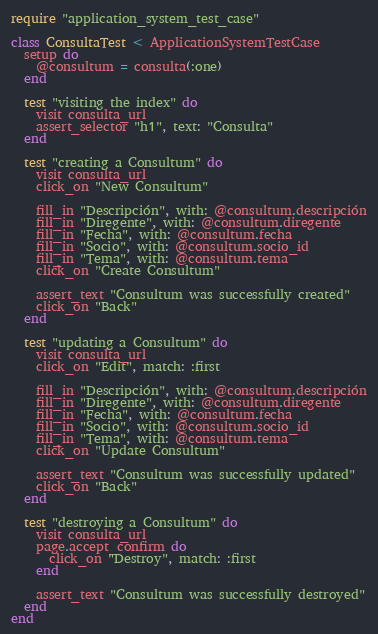<code> <loc_0><loc_0><loc_500><loc_500><_Ruby_>require "application_system_test_case"

class ConsultaTest < ApplicationSystemTestCase
  setup do
    @consultum = consulta(:one)
  end

  test "visiting the index" do
    visit consulta_url
    assert_selector "h1", text: "Consulta"
  end

  test "creating a Consultum" do
    visit consulta_url
    click_on "New Consultum"

    fill_in "Descripción", with: @consultum.descripción
    fill_in "Diregente", with: @consultum.diregente
    fill_in "Fecha", with: @consultum.fecha
    fill_in "Socio", with: @consultum.socio_id
    fill_in "Tema", with: @consultum.tema
    click_on "Create Consultum"

    assert_text "Consultum was successfully created"
    click_on "Back"
  end

  test "updating a Consultum" do
    visit consulta_url
    click_on "Edit", match: :first

    fill_in "Descripción", with: @consultum.descripción
    fill_in "Diregente", with: @consultum.diregente
    fill_in "Fecha", with: @consultum.fecha
    fill_in "Socio", with: @consultum.socio_id
    fill_in "Tema", with: @consultum.tema
    click_on "Update Consultum"

    assert_text "Consultum was successfully updated"
    click_on "Back"
  end

  test "destroying a Consultum" do
    visit consulta_url
    page.accept_confirm do
      click_on "Destroy", match: :first
    end

    assert_text "Consultum was successfully destroyed"
  end
end
</code> 